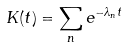<formula> <loc_0><loc_0><loc_500><loc_500>K ( t ) = \sum _ { n } e ^ { - \lambda _ { n } t }</formula> 